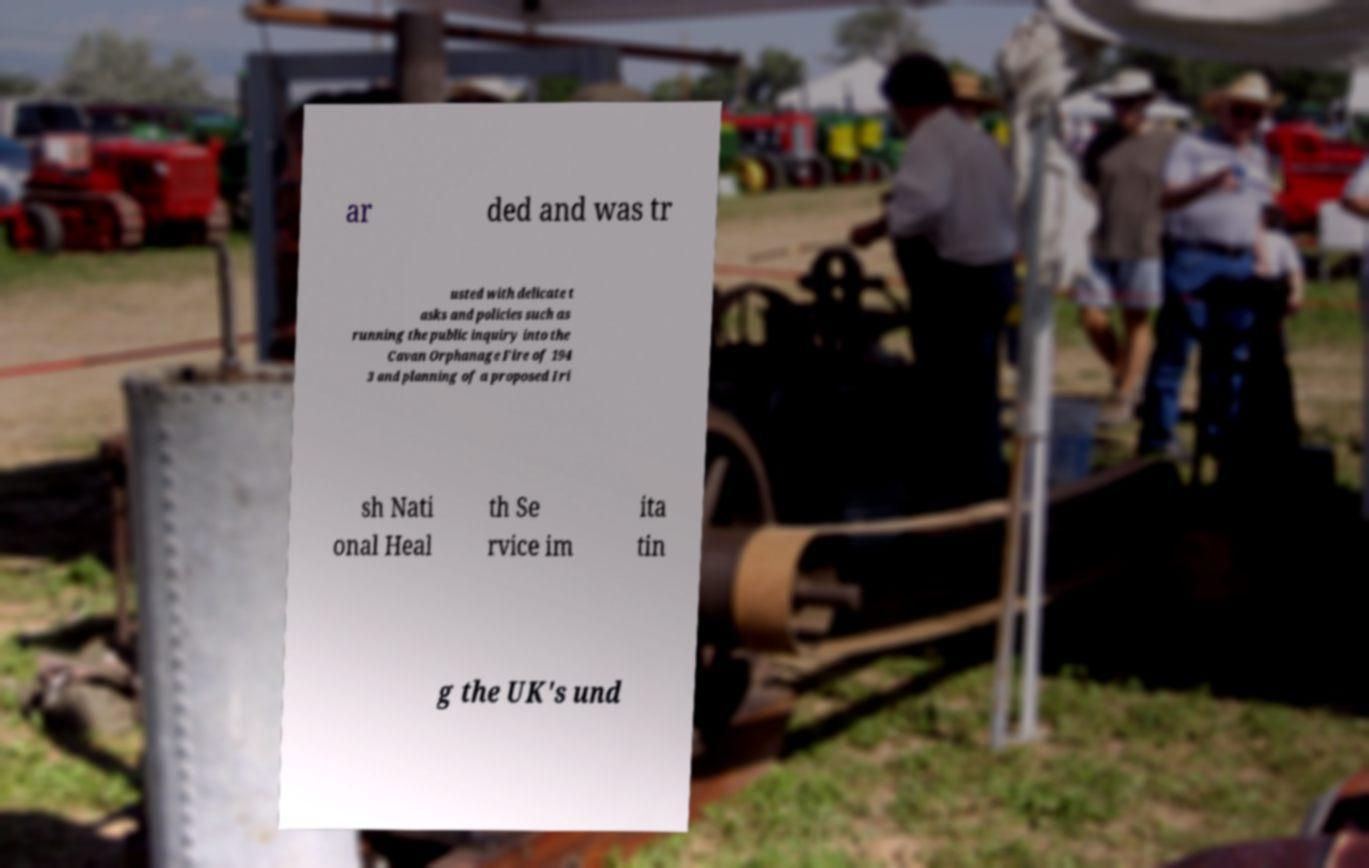Could you assist in decoding the text presented in this image and type it out clearly? ar ded and was tr usted with delicate t asks and policies such as running the public inquiry into the Cavan Orphanage Fire of 194 3 and planning of a proposed Iri sh Nati onal Heal th Se rvice im ita tin g the UK's und 